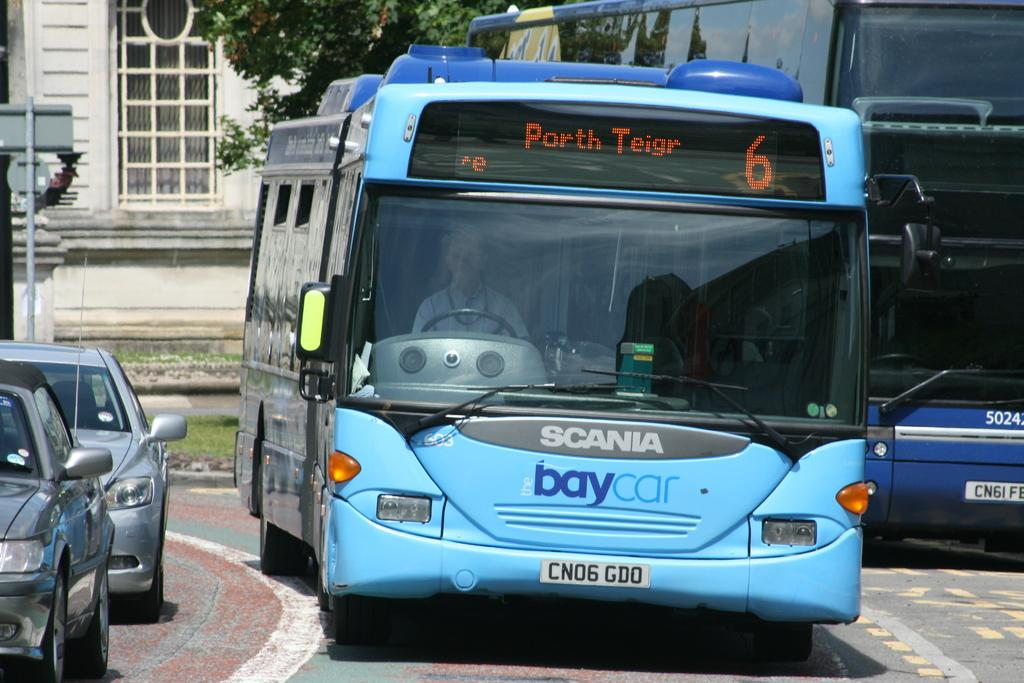How many buses are in the image? There are two buses in the image. How many cars are in the image? There are two cars in the image. What are the vehicles doing in the image? The vehicles are moving on the road. What can be seen in the background of the image? There is a building, a pole, and trees in the background of the image. What type of advice can be seen written on the dime in the image? There is no dime present in the image, and therefore no advice can be seen written on it. 